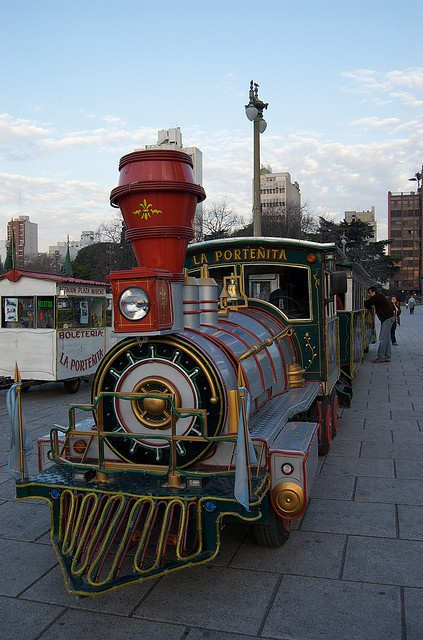Describe the objects in this image and their specific colors. I can see train in lightblue, black, gray, maroon, and olive tones, people in lightblue, black, and gray tones, people in lightblue, black, gray, and maroon tones, people in lightblue, gray, and black tones, and people in black, gray, and lightblue tones in this image. 